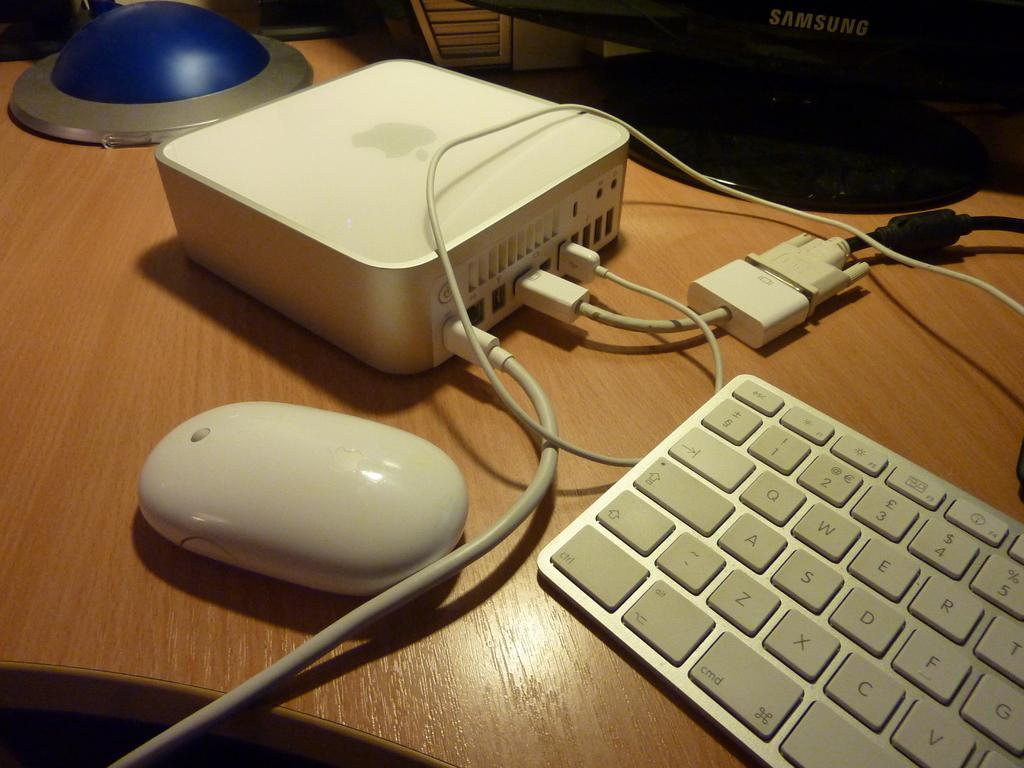What piece of furniture is present in the image? There is a table in the image. What electronic device is on the table? There is a keyboard on the table. What is used for controlling the cursor on the screen? There is a mouse on the table. What type of cable is present on the table? There is a connector on the table. Can you describe any other items on the table? There are other unspecified items on the table. How does the keyboard participate in the argument happening in the image? There is no argument present in the image; it only shows a table with various items on it. 